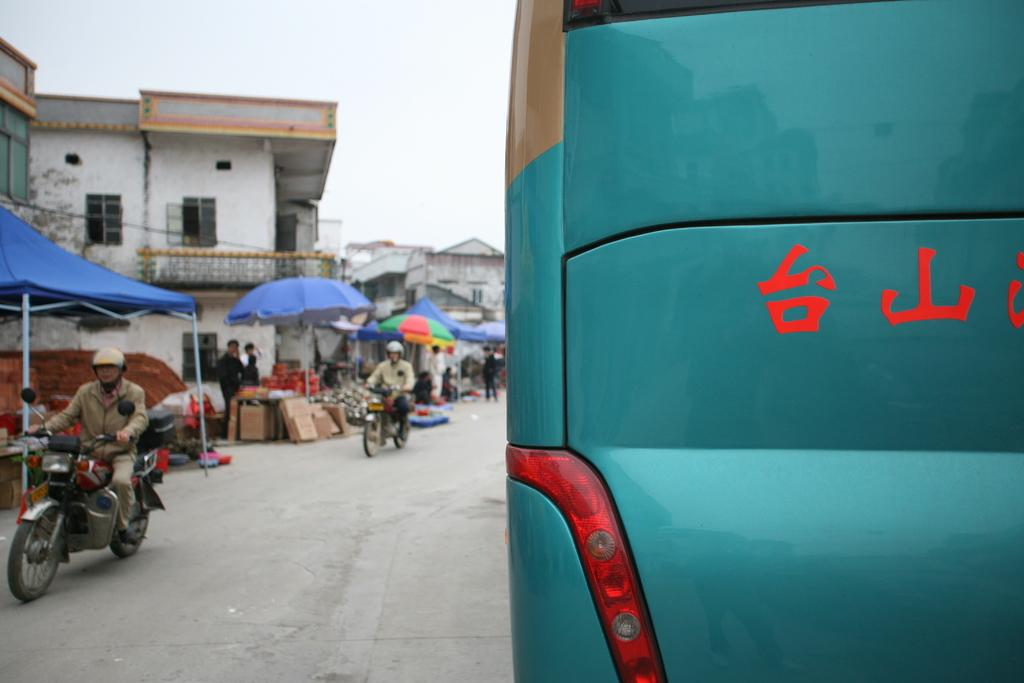What are the people in the image doing? The people in the image are on bikes. What else can be seen in the image besides the people on bikes? There is a vehicle and shades in the image. What type of structures are visible in the image? There are buildings in the image. What scientific discovery is being made by the people on bikes in the image? There is no indication of a scientific discovery being made in the image; the people are simply riding bikes. 